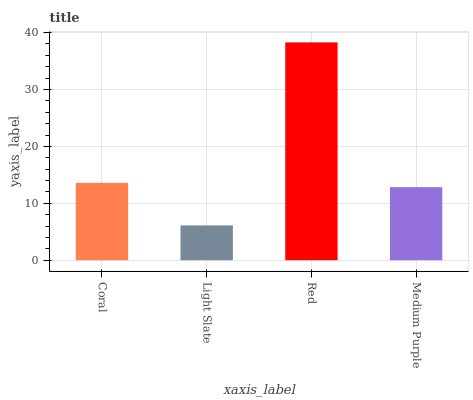Is Red the minimum?
Answer yes or no. No. Is Light Slate the maximum?
Answer yes or no. No. Is Red greater than Light Slate?
Answer yes or no. Yes. Is Light Slate less than Red?
Answer yes or no. Yes. Is Light Slate greater than Red?
Answer yes or no. No. Is Red less than Light Slate?
Answer yes or no. No. Is Coral the high median?
Answer yes or no. Yes. Is Medium Purple the low median?
Answer yes or no. Yes. Is Light Slate the high median?
Answer yes or no. No. Is Coral the low median?
Answer yes or no. No. 